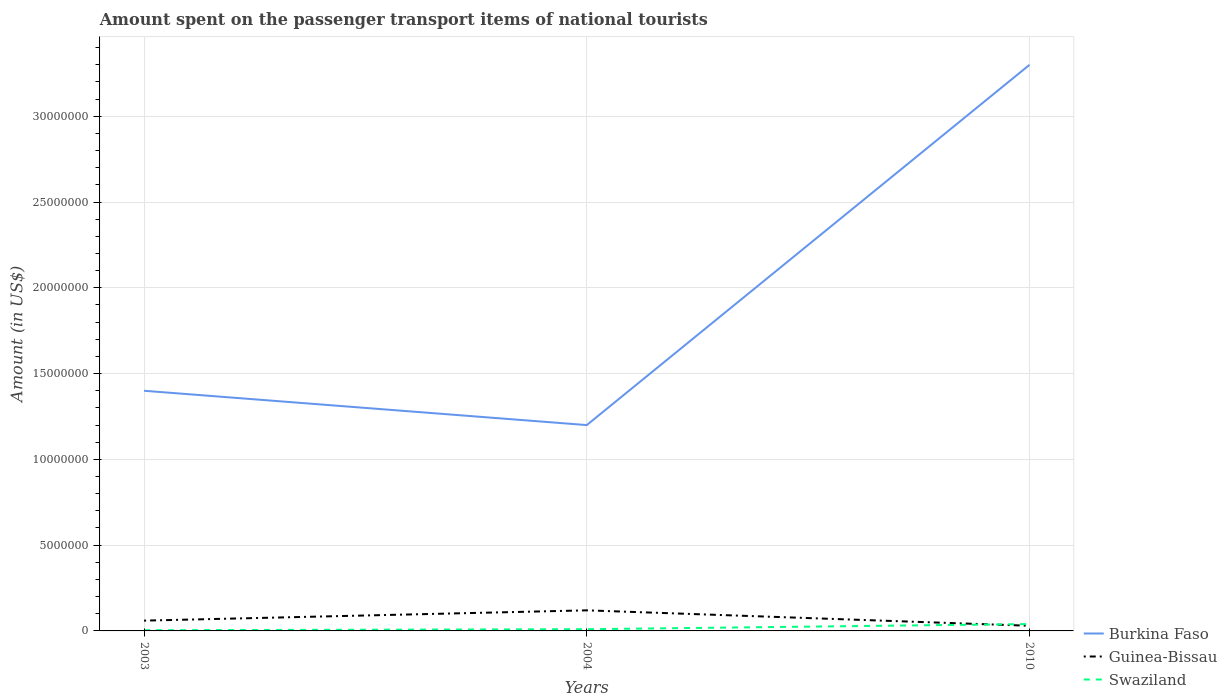Is the number of lines equal to the number of legend labels?
Offer a terse response. Yes. What is the total amount spent on the passenger transport items of national tourists in Burkina Faso in the graph?
Keep it short and to the point. -1.90e+07. Is the amount spent on the passenger transport items of national tourists in Swaziland strictly greater than the amount spent on the passenger transport items of national tourists in Burkina Faso over the years?
Your response must be concise. Yes. How many lines are there?
Your answer should be compact. 3. How many years are there in the graph?
Ensure brevity in your answer.  3. What is the difference between two consecutive major ticks on the Y-axis?
Your answer should be very brief. 5.00e+06. Are the values on the major ticks of Y-axis written in scientific E-notation?
Ensure brevity in your answer.  No. Where does the legend appear in the graph?
Make the answer very short. Bottom right. How are the legend labels stacked?
Your answer should be very brief. Vertical. What is the title of the graph?
Offer a very short reply. Amount spent on the passenger transport items of national tourists. Does "Turkey" appear as one of the legend labels in the graph?
Make the answer very short. No. What is the label or title of the Y-axis?
Your answer should be compact. Amount (in US$). What is the Amount (in US$) of Burkina Faso in 2003?
Ensure brevity in your answer.  1.40e+07. What is the Amount (in US$) of Guinea-Bissau in 2004?
Your answer should be compact. 1.20e+06. What is the Amount (in US$) of Burkina Faso in 2010?
Provide a succinct answer. 3.30e+07. What is the Amount (in US$) in Guinea-Bissau in 2010?
Your response must be concise. 3.00e+05. What is the Amount (in US$) in Swaziland in 2010?
Offer a very short reply. 4.00e+05. Across all years, what is the maximum Amount (in US$) in Burkina Faso?
Keep it short and to the point. 3.30e+07. Across all years, what is the maximum Amount (in US$) in Guinea-Bissau?
Offer a terse response. 1.20e+06. Across all years, what is the minimum Amount (in US$) of Guinea-Bissau?
Ensure brevity in your answer.  3.00e+05. Across all years, what is the minimum Amount (in US$) of Swaziland?
Give a very brief answer. 4.00e+04. What is the total Amount (in US$) of Burkina Faso in the graph?
Keep it short and to the point. 5.90e+07. What is the total Amount (in US$) in Guinea-Bissau in the graph?
Ensure brevity in your answer.  2.10e+06. What is the total Amount (in US$) of Swaziland in the graph?
Offer a terse response. 5.40e+05. What is the difference between the Amount (in US$) in Burkina Faso in 2003 and that in 2004?
Give a very brief answer. 2.00e+06. What is the difference between the Amount (in US$) in Guinea-Bissau in 2003 and that in 2004?
Your answer should be very brief. -6.00e+05. What is the difference between the Amount (in US$) in Swaziland in 2003 and that in 2004?
Offer a very short reply. -6.00e+04. What is the difference between the Amount (in US$) of Burkina Faso in 2003 and that in 2010?
Keep it short and to the point. -1.90e+07. What is the difference between the Amount (in US$) in Swaziland in 2003 and that in 2010?
Ensure brevity in your answer.  -3.60e+05. What is the difference between the Amount (in US$) of Burkina Faso in 2004 and that in 2010?
Keep it short and to the point. -2.10e+07. What is the difference between the Amount (in US$) in Burkina Faso in 2003 and the Amount (in US$) in Guinea-Bissau in 2004?
Make the answer very short. 1.28e+07. What is the difference between the Amount (in US$) of Burkina Faso in 2003 and the Amount (in US$) of Swaziland in 2004?
Your answer should be compact. 1.39e+07. What is the difference between the Amount (in US$) of Burkina Faso in 2003 and the Amount (in US$) of Guinea-Bissau in 2010?
Your answer should be compact. 1.37e+07. What is the difference between the Amount (in US$) in Burkina Faso in 2003 and the Amount (in US$) in Swaziland in 2010?
Give a very brief answer. 1.36e+07. What is the difference between the Amount (in US$) of Burkina Faso in 2004 and the Amount (in US$) of Guinea-Bissau in 2010?
Your answer should be very brief. 1.17e+07. What is the difference between the Amount (in US$) of Burkina Faso in 2004 and the Amount (in US$) of Swaziland in 2010?
Provide a short and direct response. 1.16e+07. What is the average Amount (in US$) in Burkina Faso per year?
Make the answer very short. 1.97e+07. What is the average Amount (in US$) of Guinea-Bissau per year?
Give a very brief answer. 7.00e+05. What is the average Amount (in US$) in Swaziland per year?
Give a very brief answer. 1.80e+05. In the year 2003, what is the difference between the Amount (in US$) of Burkina Faso and Amount (in US$) of Guinea-Bissau?
Your response must be concise. 1.34e+07. In the year 2003, what is the difference between the Amount (in US$) in Burkina Faso and Amount (in US$) in Swaziland?
Provide a succinct answer. 1.40e+07. In the year 2003, what is the difference between the Amount (in US$) in Guinea-Bissau and Amount (in US$) in Swaziland?
Keep it short and to the point. 5.60e+05. In the year 2004, what is the difference between the Amount (in US$) in Burkina Faso and Amount (in US$) in Guinea-Bissau?
Offer a very short reply. 1.08e+07. In the year 2004, what is the difference between the Amount (in US$) in Burkina Faso and Amount (in US$) in Swaziland?
Your answer should be very brief. 1.19e+07. In the year 2004, what is the difference between the Amount (in US$) of Guinea-Bissau and Amount (in US$) of Swaziland?
Your answer should be compact. 1.10e+06. In the year 2010, what is the difference between the Amount (in US$) in Burkina Faso and Amount (in US$) in Guinea-Bissau?
Keep it short and to the point. 3.27e+07. In the year 2010, what is the difference between the Amount (in US$) of Burkina Faso and Amount (in US$) of Swaziland?
Offer a very short reply. 3.26e+07. In the year 2010, what is the difference between the Amount (in US$) of Guinea-Bissau and Amount (in US$) of Swaziland?
Offer a terse response. -1.00e+05. What is the ratio of the Amount (in US$) in Guinea-Bissau in 2003 to that in 2004?
Provide a short and direct response. 0.5. What is the ratio of the Amount (in US$) of Swaziland in 2003 to that in 2004?
Give a very brief answer. 0.4. What is the ratio of the Amount (in US$) in Burkina Faso in 2003 to that in 2010?
Offer a terse response. 0.42. What is the ratio of the Amount (in US$) in Guinea-Bissau in 2003 to that in 2010?
Offer a very short reply. 2. What is the ratio of the Amount (in US$) in Swaziland in 2003 to that in 2010?
Ensure brevity in your answer.  0.1. What is the ratio of the Amount (in US$) in Burkina Faso in 2004 to that in 2010?
Make the answer very short. 0.36. What is the ratio of the Amount (in US$) of Guinea-Bissau in 2004 to that in 2010?
Your answer should be compact. 4. What is the ratio of the Amount (in US$) of Swaziland in 2004 to that in 2010?
Your response must be concise. 0.25. What is the difference between the highest and the second highest Amount (in US$) of Burkina Faso?
Your answer should be very brief. 1.90e+07. What is the difference between the highest and the second highest Amount (in US$) of Guinea-Bissau?
Give a very brief answer. 6.00e+05. What is the difference between the highest and the second highest Amount (in US$) in Swaziland?
Your answer should be compact. 3.00e+05. What is the difference between the highest and the lowest Amount (in US$) in Burkina Faso?
Offer a terse response. 2.10e+07. 